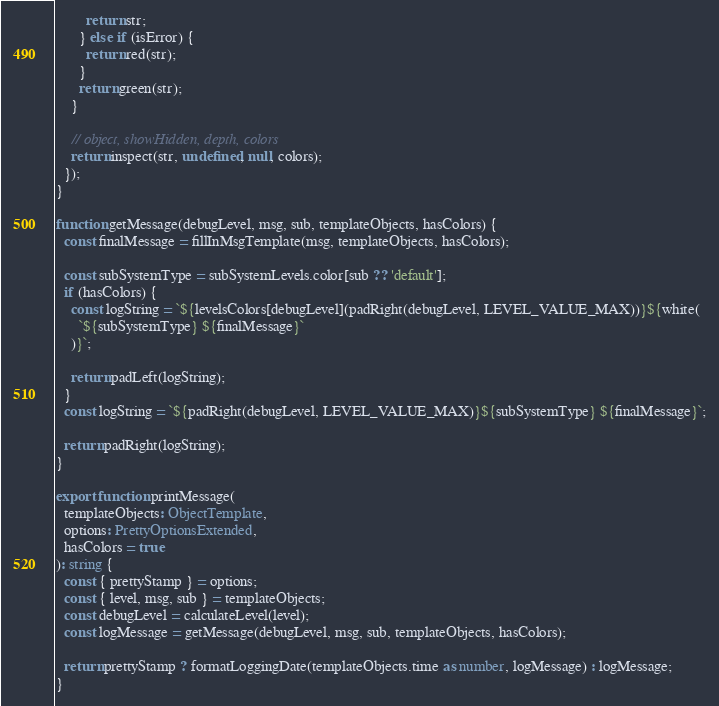<code> <loc_0><loc_0><loc_500><loc_500><_TypeScript_>        return str;
      } else if (isError) {
        return red(str);
      }
      return green(str);
    }

    // object, showHidden, depth, colors
    return inspect(str, undefined, null, colors);
  });
}

function getMessage(debugLevel, msg, sub, templateObjects, hasColors) {
  const finalMessage = fillInMsgTemplate(msg, templateObjects, hasColors);

  const subSystemType = subSystemLevels.color[sub ?? 'default'];
  if (hasColors) {
    const logString = `${levelsColors[debugLevel](padRight(debugLevel, LEVEL_VALUE_MAX))}${white(
      `${subSystemType} ${finalMessage}`
    )}`;

    return padLeft(logString);
  }
  const logString = `${padRight(debugLevel, LEVEL_VALUE_MAX)}${subSystemType} ${finalMessage}`;

  return padRight(logString);
}

export function printMessage(
  templateObjects: ObjectTemplate,
  options: PrettyOptionsExtended,
  hasColors = true
): string {
  const { prettyStamp } = options;
  const { level, msg, sub } = templateObjects;
  const debugLevel = calculateLevel(level);
  const logMessage = getMessage(debugLevel, msg, sub, templateObjects, hasColors);

  return prettyStamp ? formatLoggingDate(templateObjects.time as number, logMessage) : logMessage;
}
</code> 